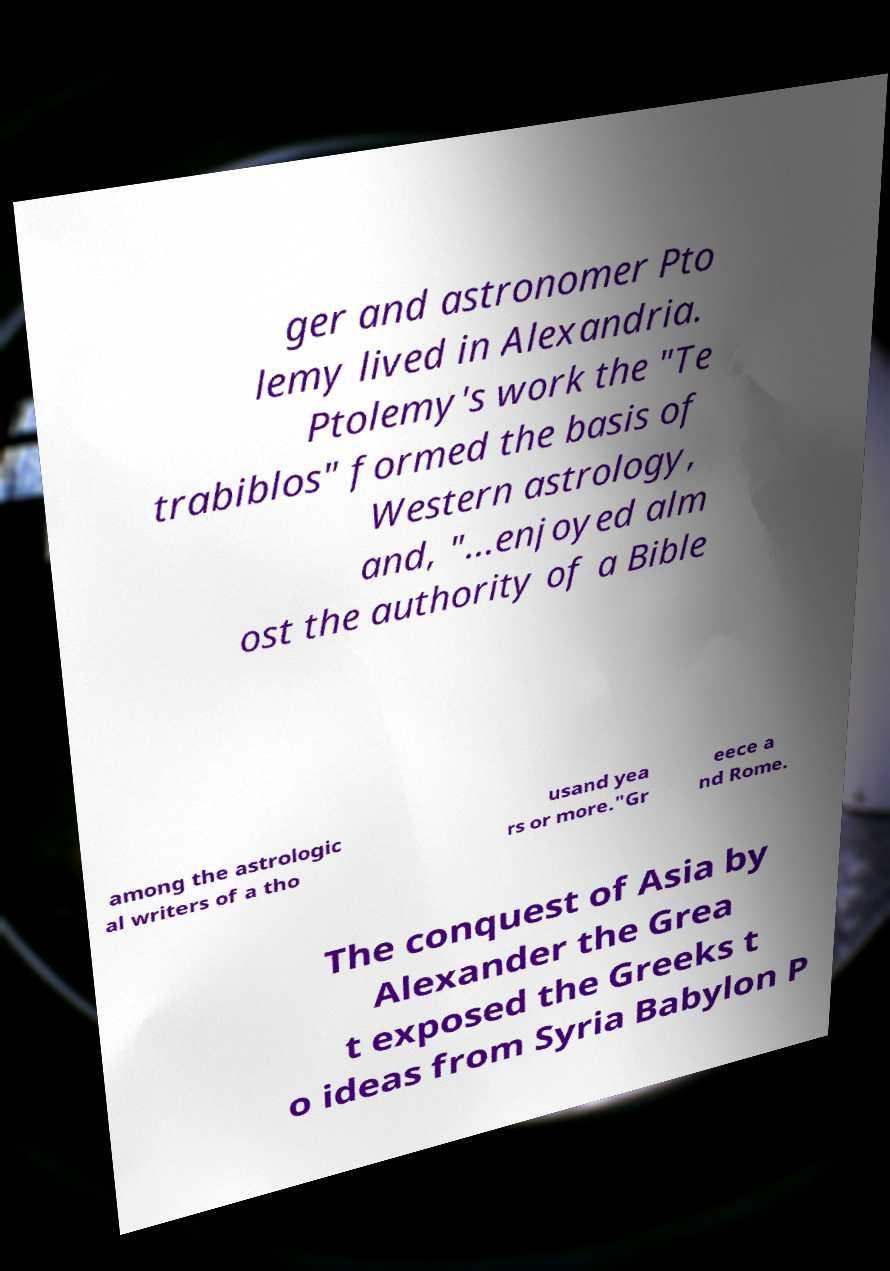Could you assist in decoding the text presented in this image and type it out clearly? ger and astronomer Pto lemy lived in Alexandria. Ptolemy's work the "Te trabiblos" formed the basis of Western astrology, and, "...enjoyed alm ost the authority of a Bible among the astrologic al writers of a tho usand yea rs or more."Gr eece a nd Rome. The conquest of Asia by Alexander the Grea t exposed the Greeks t o ideas from Syria Babylon P 